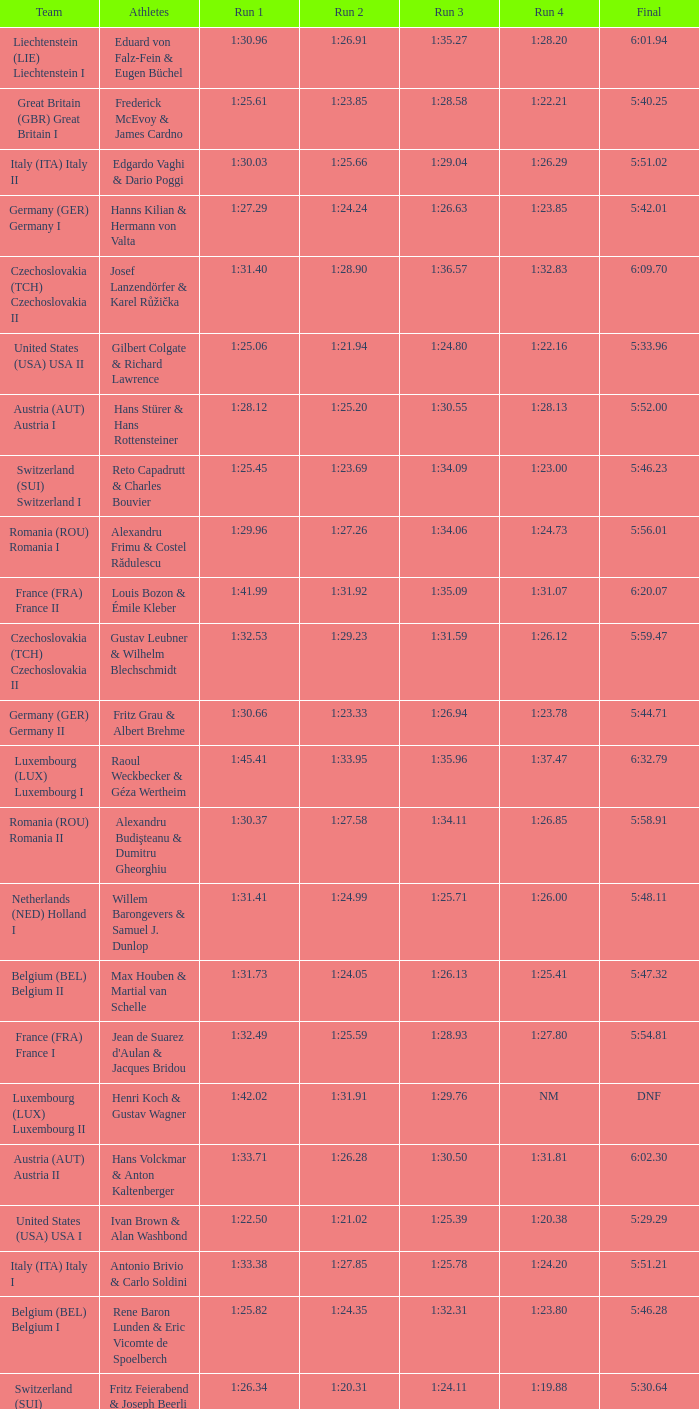Which Final has a Run 2 of 1:27.58? 5:58.91. 